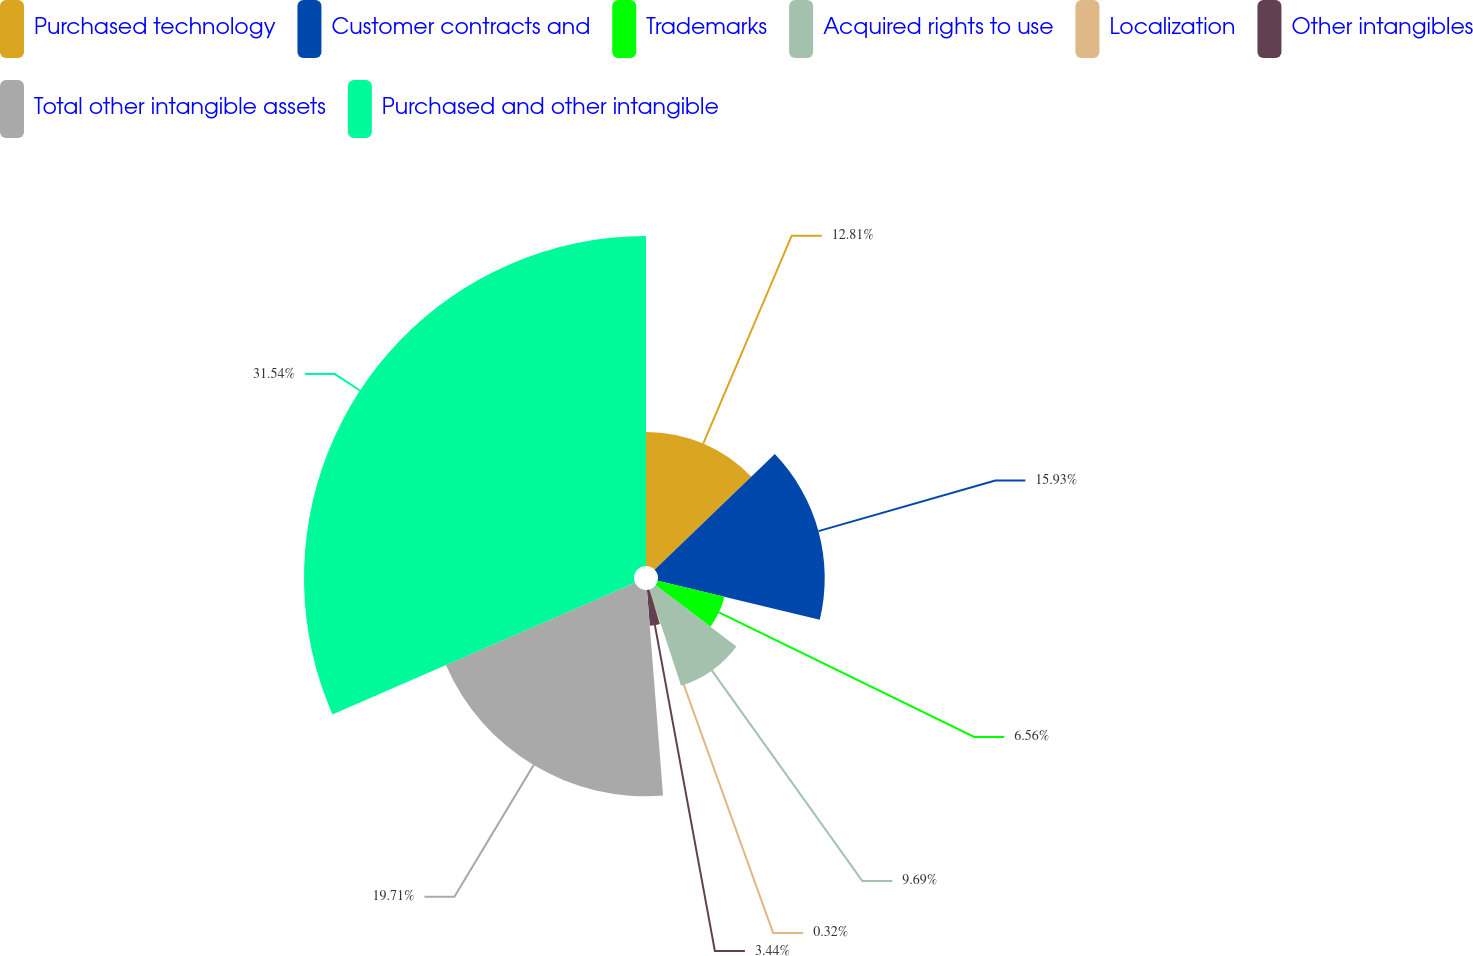<chart> <loc_0><loc_0><loc_500><loc_500><pie_chart><fcel>Purchased technology<fcel>Customer contracts and<fcel>Trademarks<fcel>Acquired rights to use<fcel>Localization<fcel>Other intangibles<fcel>Total other intangible assets<fcel>Purchased and other intangible<nl><fcel>12.81%<fcel>15.93%<fcel>6.56%<fcel>9.69%<fcel>0.32%<fcel>3.44%<fcel>19.71%<fcel>31.53%<nl></chart> 